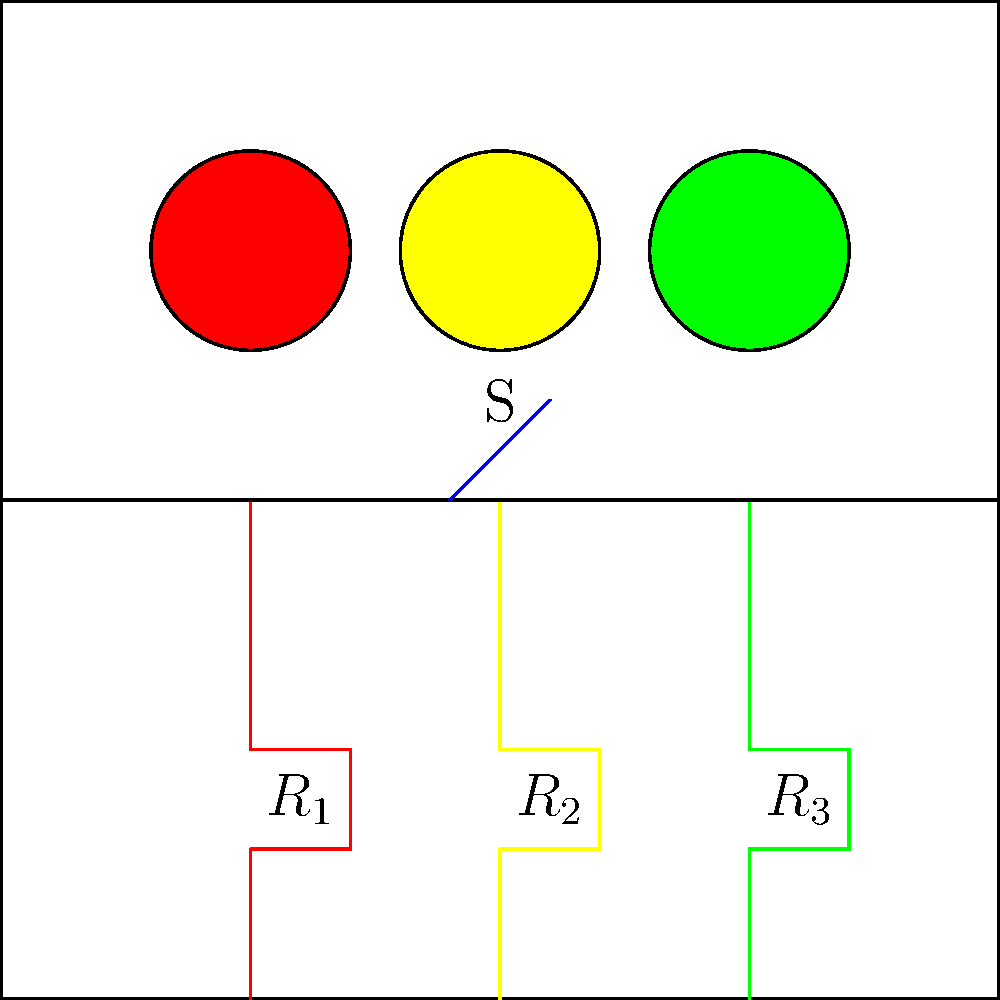In this simple LED traffic light system, which color LED(s) will be illuminated when the switch S is closed, assuming all resistors have the same value and the power supply is sufficient to light all LEDs? To determine which LED(s) will be illuminated when the switch is closed, we need to analyze the circuit:

1. The circuit shows three LEDs (red, yellow, and green) connected in parallel.
2. Each LED has its own resistor ($R_1$, $R_2$, and $R_3$) connected in series.
3. The switch S is connected in series with the entire parallel arrangement of LED-resistor pairs.
4. When the switch is closed, it completes the circuit, allowing current to flow.
5. Since all resistors have the same value and the LEDs are connected in parallel, the voltage across each LED-resistor pair will be the same.
6. Assuming the power supply is sufficient to light all LEDs, and the resistor values are appropriate for the LEDs, all three LEDs will receive enough current to illuminate.
7. In a real traffic light system, additional control circuitry would be used to illuminate the LEDs in the correct sequence. However, this simple circuit does not include such control mechanisms.

Therefore, when the switch S is closed, all three LEDs (red, yellow, and green) will be illuminated simultaneously.
Answer: All three LEDs (red, yellow, and green) 